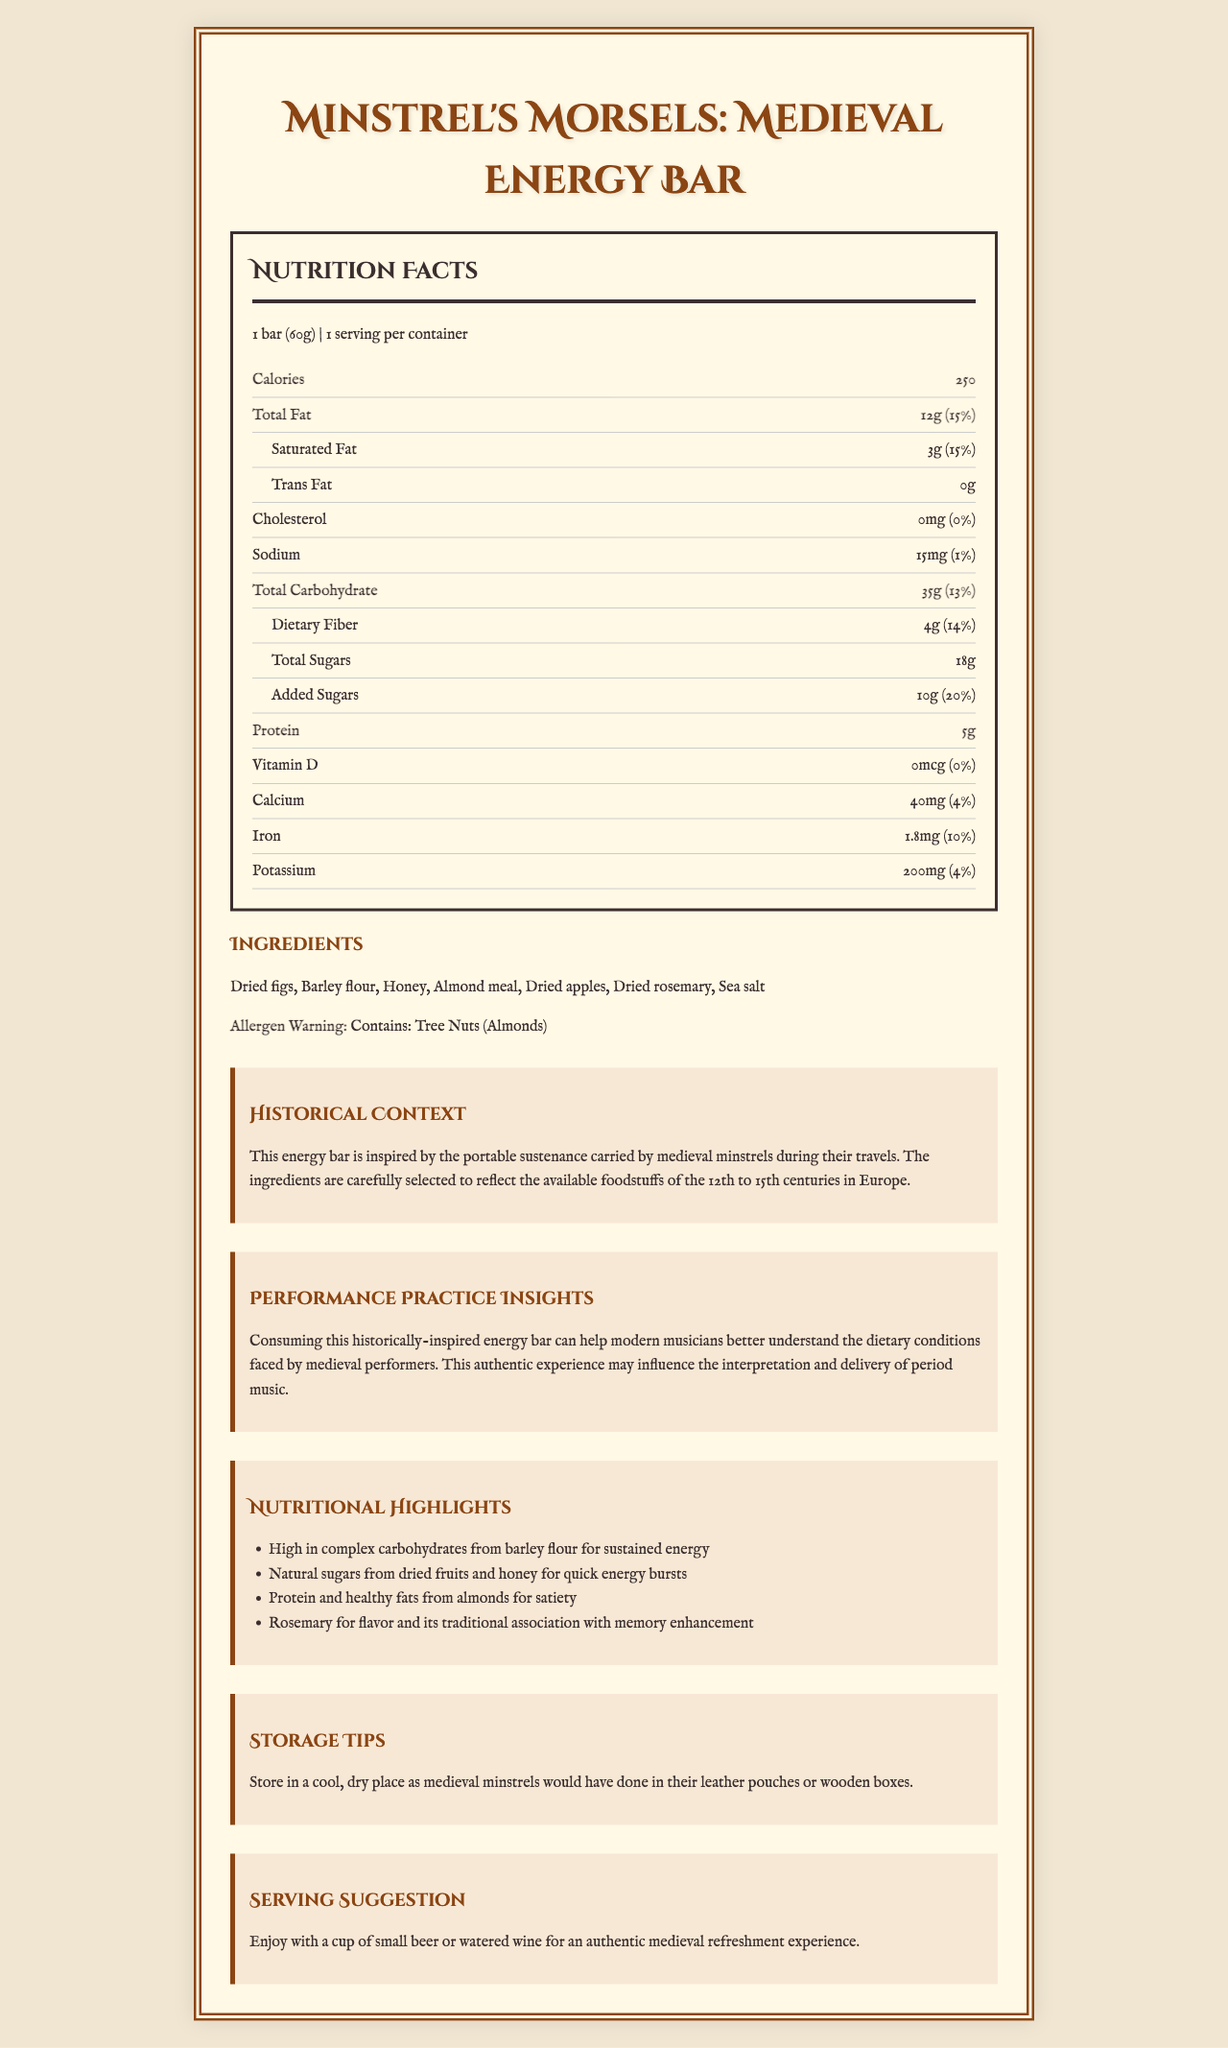what is the serving size of the Medieval Energy Bar? The serving size is mentioned right at the beginning of the Nutrition Facts section.
Answer: 1 bar (60g) how many grams of total carbohydrates are in one serving? The Nutrition Facts section lists the total carbohydrate amount per serving as 35g.
Answer: 35g how much protein does the energy bar provide? The Nutrition Facts section specifies that the energy bar provides 5g of protein per serving.
Answer: 5g does the energy bar contain any trans fat? The document states that the trans fat amount is 0g.
Answer: No what are the first three ingredients listed for the energy bar? The ingredients are listed in the Ingredients section, and the first three are dried figs, barley flour, and honey.
Answer: Dried figs, Barley flour, Honey which of the following vitamins and minerals are present in the energy bar? A. Vitamin C B. Iron C. Magnesium D. Potassium The Nutrition Facts section lists iron and potassium as present in the energy bar, but does not mention Vitamin C or Magnesium.
Answer: B. Iron and D. Potassium what percentage of the daily value for dietary fiber does the energy bar provide? The Nutrition Facts section shows that the energy bar provides 14% of the daily value for dietary fiber.
Answer: 14% does the energy bar contain any cholesterol? The Nutrition Facts section indicates 0mg of cholesterol per serving.
Answer: No how should the energy bar be stored? A. In the refrigerator B. At room temperature C. In a freezer D. In a cool, dry place The Storage Tips section advises storing the energy bar in a cool, dry place.
Answer: D. In a cool, dry place is there an allergen warning provided for the energy bar? The Ingredients section includes an allergen warning about tree nuts (almonds).
Answer: Yes what are the calories per serving in the energy bar? The Nutrition Facts section lists the calories per serving as 250.
Answer: 250 summarize the main idea of the document This summary encapsulates the totality of the information presented in the document.
Answer: The document provides detailed information about the Minstrel's Morsels: Medieval Energy Bar, including its nutritional facts, ingredients, historical context, performance practice insights, storage tips, and serving suggestions. The energy bar is inspired by medieval minstrel sustenance and aims to offer an authentic period-accurate dietary experience. what is the role of rosemary in the energy bar, according to the document? The document mentions that rosemary is included for flavor and its traditional association with memory enhancement.
Answer: Flavor and memory enhancement can we determine the exact medieval recipes and techniques used to make the energy bar based on the document? The document provides only ingredients and historical context but lacks specific medieval recipes and techniques used for making the energy bar.
Answer: No 